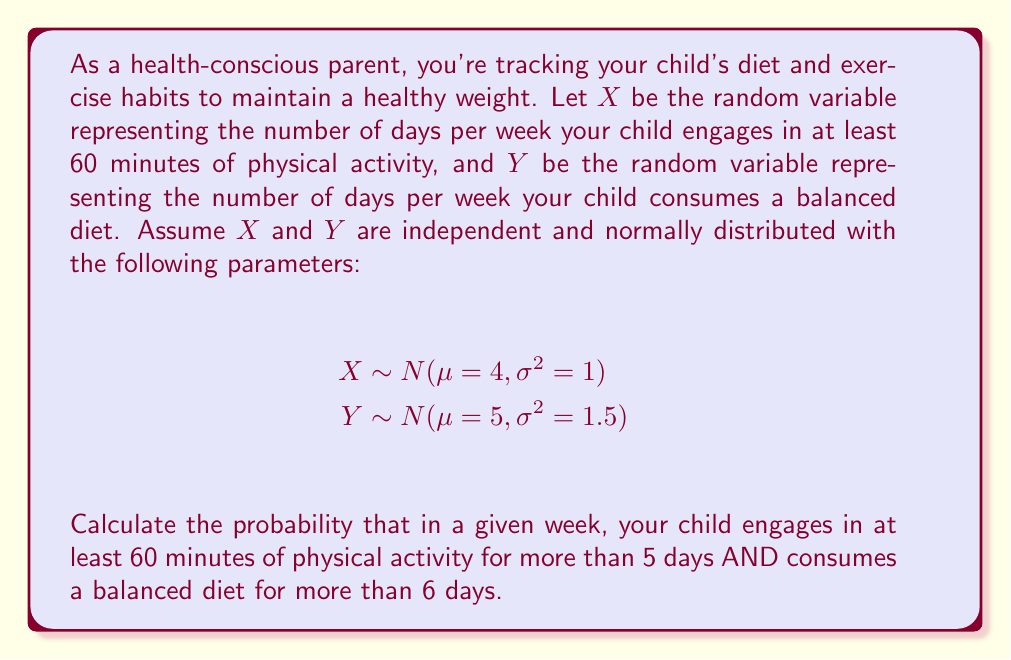Can you answer this question? To solve this problem, we need to follow these steps:

1. Find P(X > 5) for the physical activity:
   First, we standardize X:
   $$Z_X = \frac{X - μ_X}{σ_X} = \frac{5 - 4}{1} = 1$$
   P(X > 5) = P(Z > 1) = 1 - Φ(1) ≈ 0.1587

2. Find P(Y > 6) for the balanced diet:
   Standardize Y:
   $$Z_Y = \frac{Y - μ_Y}{σ_Y} = \frac{6 - 5}{\sqrt{1.5}} ≈ 0.8165$$
   P(Y > 6) = P(Z > 0.8165) = 1 - Φ(0.8165) ≈ 0.2071

3. Since X and Y are independent, we can multiply the probabilities:
   P(X > 5 and Y > 6) = P(X > 5) × P(Y > 6)
   ≈ 0.1587 × 0.2071 ≈ 0.0329

Therefore, the probability that your child engages in at least 60 minutes of physical activity for more than 5 days AND consumes a balanced diet for more than 6 days in a given week is approximately 0.0329 or 3.29%.
Answer: 0.0329 or 3.29% 